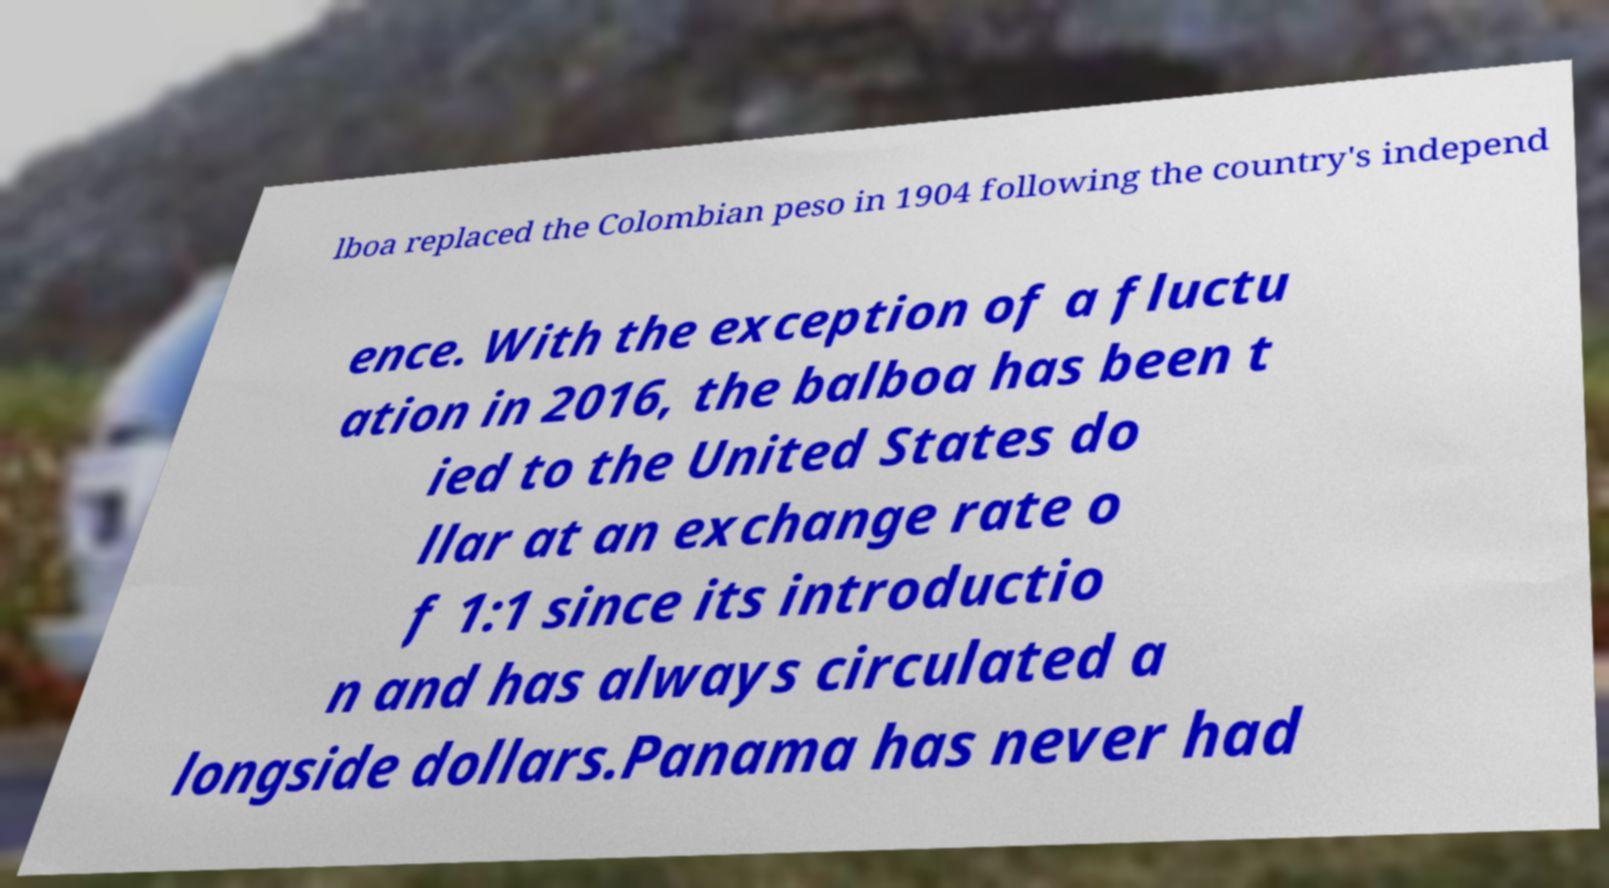Could you assist in decoding the text presented in this image and type it out clearly? lboa replaced the Colombian peso in 1904 following the country's independ ence. With the exception of a fluctu ation in 2016, the balboa has been t ied to the United States do llar at an exchange rate o f 1:1 since its introductio n and has always circulated a longside dollars.Panama has never had 